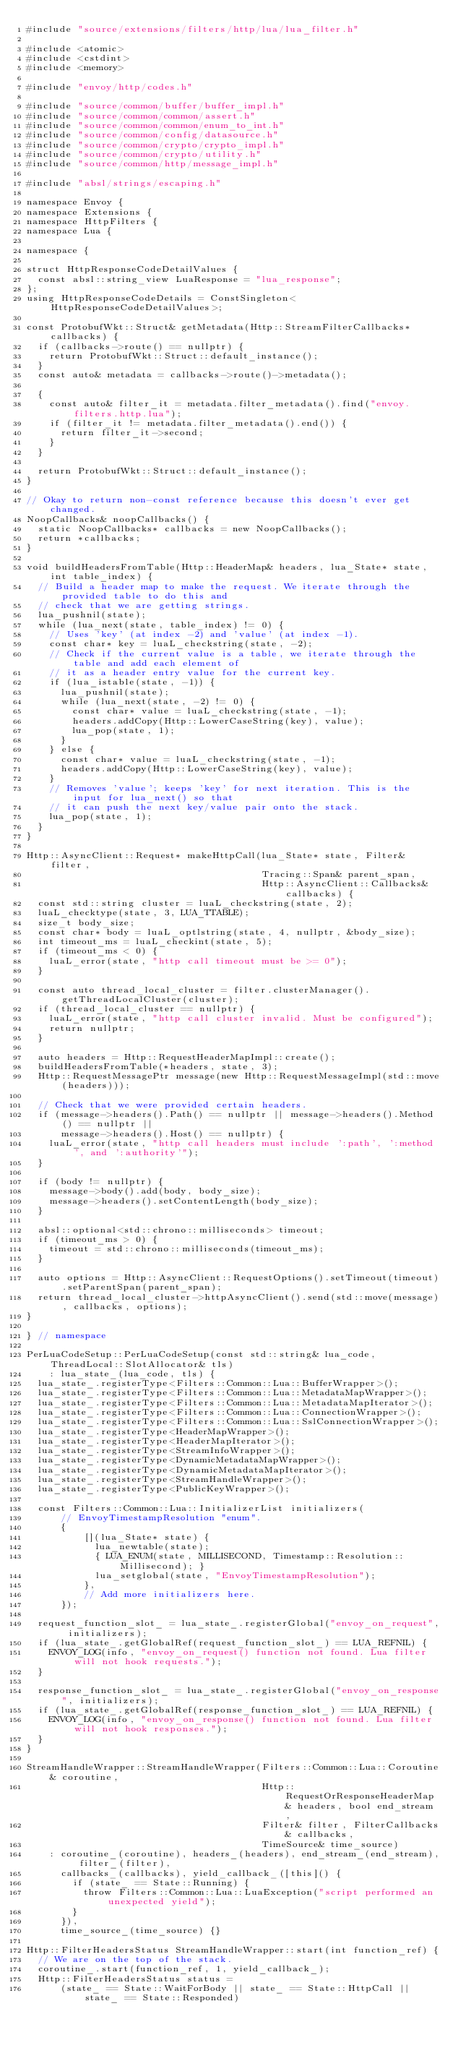<code> <loc_0><loc_0><loc_500><loc_500><_C++_>#include "source/extensions/filters/http/lua/lua_filter.h"

#include <atomic>
#include <cstdint>
#include <memory>

#include "envoy/http/codes.h"

#include "source/common/buffer/buffer_impl.h"
#include "source/common/common/assert.h"
#include "source/common/common/enum_to_int.h"
#include "source/common/config/datasource.h"
#include "source/common/crypto/crypto_impl.h"
#include "source/common/crypto/utility.h"
#include "source/common/http/message_impl.h"

#include "absl/strings/escaping.h"

namespace Envoy {
namespace Extensions {
namespace HttpFilters {
namespace Lua {

namespace {

struct HttpResponseCodeDetailValues {
  const absl::string_view LuaResponse = "lua_response";
};
using HttpResponseCodeDetails = ConstSingleton<HttpResponseCodeDetailValues>;

const ProtobufWkt::Struct& getMetadata(Http::StreamFilterCallbacks* callbacks) {
  if (callbacks->route() == nullptr) {
    return ProtobufWkt::Struct::default_instance();
  }
  const auto& metadata = callbacks->route()->metadata();

  {
    const auto& filter_it = metadata.filter_metadata().find("envoy.filters.http.lua");
    if (filter_it != metadata.filter_metadata().end()) {
      return filter_it->second;
    }
  }

  return ProtobufWkt::Struct::default_instance();
}

// Okay to return non-const reference because this doesn't ever get changed.
NoopCallbacks& noopCallbacks() {
  static NoopCallbacks* callbacks = new NoopCallbacks();
  return *callbacks;
}

void buildHeadersFromTable(Http::HeaderMap& headers, lua_State* state, int table_index) {
  // Build a header map to make the request. We iterate through the provided table to do this and
  // check that we are getting strings.
  lua_pushnil(state);
  while (lua_next(state, table_index) != 0) {
    // Uses 'key' (at index -2) and 'value' (at index -1).
    const char* key = luaL_checkstring(state, -2);
    // Check if the current value is a table, we iterate through the table and add each element of
    // it as a header entry value for the current key.
    if (lua_istable(state, -1)) {
      lua_pushnil(state);
      while (lua_next(state, -2) != 0) {
        const char* value = luaL_checkstring(state, -1);
        headers.addCopy(Http::LowerCaseString(key), value);
        lua_pop(state, 1);
      }
    } else {
      const char* value = luaL_checkstring(state, -1);
      headers.addCopy(Http::LowerCaseString(key), value);
    }
    // Removes 'value'; keeps 'key' for next iteration. This is the input for lua_next() so that
    // it can push the next key/value pair onto the stack.
    lua_pop(state, 1);
  }
}

Http::AsyncClient::Request* makeHttpCall(lua_State* state, Filter& filter,
                                         Tracing::Span& parent_span,
                                         Http::AsyncClient::Callbacks& callbacks) {
  const std::string cluster = luaL_checkstring(state, 2);
  luaL_checktype(state, 3, LUA_TTABLE);
  size_t body_size;
  const char* body = luaL_optlstring(state, 4, nullptr, &body_size);
  int timeout_ms = luaL_checkint(state, 5);
  if (timeout_ms < 0) {
    luaL_error(state, "http call timeout must be >= 0");
  }

  const auto thread_local_cluster = filter.clusterManager().getThreadLocalCluster(cluster);
  if (thread_local_cluster == nullptr) {
    luaL_error(state, "http call cluster invalid. Must be configured");
    return nullptr;
  }

  auto headers = Http::RequestHeaderMapImpl::create();
  buildHeadersFromTable(*headers, state, 3);
  Http::RequestMessagePtr message(new Http::RequestMessageImpl(std::move(headers)));

  // Check that we were provided certain headers.
  if (message->headers().Path() == nullptr || message->headers().Method() == nullptr ||
      message->headers().Host() == nullptr) {
    luaL_error(state, "http call headers must include ':path', ':method', and ':authority'");
  }

  if (body != nullptr) {
    message->body().add(body, body_size);
    message->headers().setContentLength(body_size);
  }

  absl::optional<std::chrono::milliseconds> timeout;
  if (timeout_ms > 0) {
    timeout = std::chrono::milliseconds(timeout_ms);
  }

  auto options = Http::AsyncClient::RequestOptions().setTimeout(timeout).setParentSpan(parent_span);
  return thread_local_cluster->httpAsyncClient().send(std::move(message), callbacks, options);
}

} // namespace

PerLuaCodeSetup::PerLuaCodeSetup(const std::string& lua_code, ThreadLocal::SlotAllocator& tls)
    : lua_state_(lua_code, tls) {
  lua_state_.registerType<Filters::Common::Lua::BufferWrapper>();
  lua_state_.registerType<Filters::Common::Lua::MetadataMapWrapper>();
  lua_state_.registerType<Filters::Common::Lua::MetadataMapIterator>();
  lua_state_.registerType<Filters::Common::Lua::ConnectionWrapper>();
  lua_state_.registerType<Filters::Common::Lua::SslConnectionWrapper>();
  lua_state_.registerType<HeaderMapWrapper>();
  lua_state_.registerType<HeaderMapIterator>();
  lua_state_.registerType<StreamInfoWrapper>();
  lua_state_.registerType<DynamicMetadataMapWrapper>();
  lua_state_.registerType<DynamicMetadataMapIterator>();
  lua_state_.registerType<StreamHandleWrapper>();
  lua_state_.registerType<PublicKeyWrapper>();

  const Filters::Common::Lua::InitializerList initializers(
      // EnvoyTimestampResolution "enum".
      {
          [](lua_State* state) {
            lua_newtable(state);
            { LUA_ENUM(state, MILLISECOND, Timestamp::Resolution::Millisecond); }
            lua_setglobal(state, "EnvoyTimestampResolution");
          },
          // Add more initializers here.
      });

  request_function_slot_ = lua_state_.registerGlobal("envoy_on_request", initializers);
  if (lua_state_.getGlobalRef(request_function_slot_) == LUA_REFNIL) {
    ENVOY_LOG(info, "envoy_on_request() function not found. Lua filter will not hook requests.");
  }

  response_function_slot_ = lua_state_.registerGlobal("envoy_on_response", initializers);
  if (lua_state_.getGlobalRef(response_function_slot_) == LUA_REFNIL) {
    ENVOY_LOG(info, "envoy_on_response() function not found. Lua filter will not hook responses.");
  }
}

StreamHandleWrapper::StreamHandleWrapper(Filters::Common::Lua::Coroutine& coroutine,
                                         Http::RequestOrResponseHeaderMap& headers, bool end_stream,
                                         Filter& filter, FilterCallbacks& callbacks,
                                         TimeSource& time_source)
    : coroutine_(coroutine), headers_(headers), end_stream_(end_stream), filter_(filter),
      callbacks_(callbacks), yield_callback_([this]() {
        if (state_ == State::Running) {
          throw Filters::Common::Lua::LuaException("script performed an unexpected yield");
        }
      }),
      time_source_(time_source) {}

Http::FilterHeadersStatus StreamHandleWrapper::start(int function_ref) {
  // We are on the top of the stack.
  coroutine_.start(function_ref, 1, yield_callback_);
  Http::FilterHeadersStatus status =
      (state_ == State::WaitForBody || state_ == State::HttpCall || state_ == State::Responded)</code> 